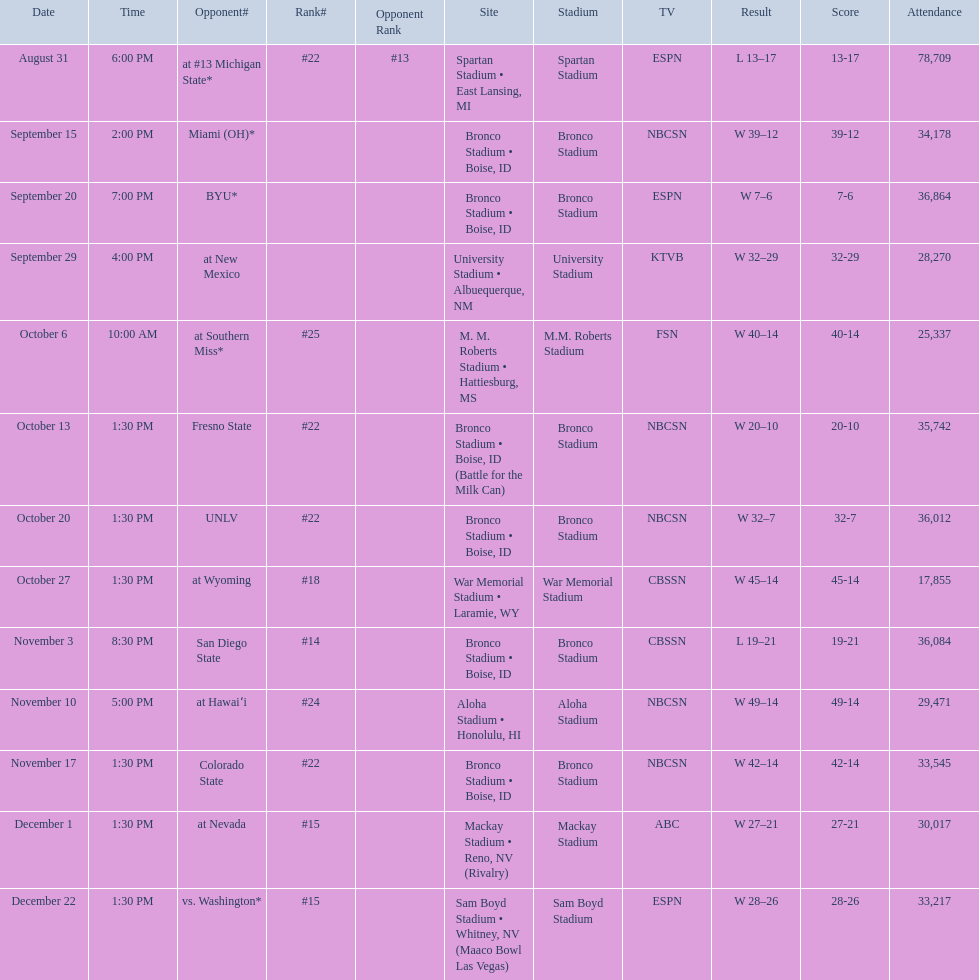What is the total number of games played at bronco stadium? 6. 